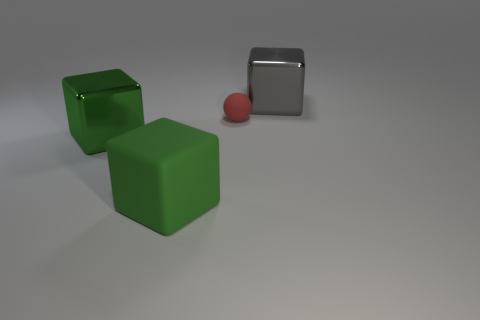How many other objects are the same size as the ball?
Offer a very short reply. 0. There is a green object in front of the shiny thing in front of the large gray block; what is its shape?
Provide a short and direct response. Cube. Is the number of small cyan metal cylinders greater than the number of red balls?
Make the answer very short. No. How many big blocks are both behind the large rubber object and left of the small matte sphere?
Your answer should be very brief. 1. What number of green rubber objects are in front of the large block behind the tiny rubber thing?
Keep it short and to the point. 1. What number of things are large metal blocks in front of the red matte ball or big metallic blocks in front of the small red rubber object?
Your answer should be very brief. 1. What material is the big gray thing that is the same shape as the big green matte object?
Provide a short and direct response. Metal. How many things are either large metal blocks that are left of the large gray metallic block or small gray rubber things?
Ensure brevity in your answer.  1. What shape is the other object that is made of the same material as the small red object?
Provide a succinct answer. Cube. What number of other big green matte objects are the same shape as the green matte object?
Your response must be concise. 0. 